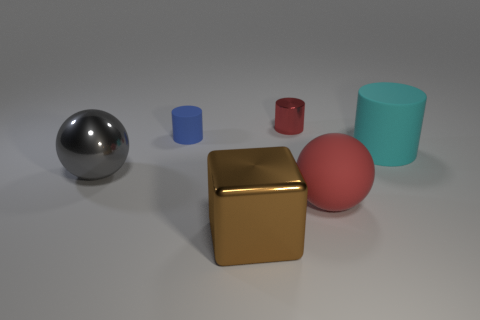There is a big ball that is in front of the ball on the left side of the matte thing in front of the gray thing; what is it made of?
Give a very brief answer. Rubber. Is the red matte thing the same shape as the gray object?
Offer a terse response. Yes. How many small things are metallic cylinders or purple matte spheres?
Provide a short and direct response. 1. Is there a matte object on the left side of the matte object in front of the gray shiny thing?
Offer a terse response. Yes. Are there any small cyan blocks?
Provide a short and direct response. No. There is a big matte thing that is to the right of the ball that is to the right of the big gray object; what color is it?
Ensure brevity in your answer.  Cyan. What material is the small blue thing that is the same shape as the large cyan matte object?
Your response must be concise. Rubber. How many spheres are the same size as the red metallic cylinder?
Keep it short and to the point. 0. There is a brown block that is made of the same material as the large gray sphere; what is its size?
Give a very brief answer. Large. How many rubber things have the same shape as the gray metal object?
Ensure brevity in your answer.  1. 